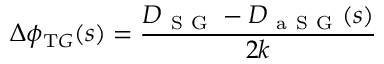<formula> <loc_0><loc_0><loc_500><loc_500>\Delta \phi _ { T G } ( s ) = \frac { D _ { S G } - D _ { a S G } ( s ) } { 2 k }</formula> 